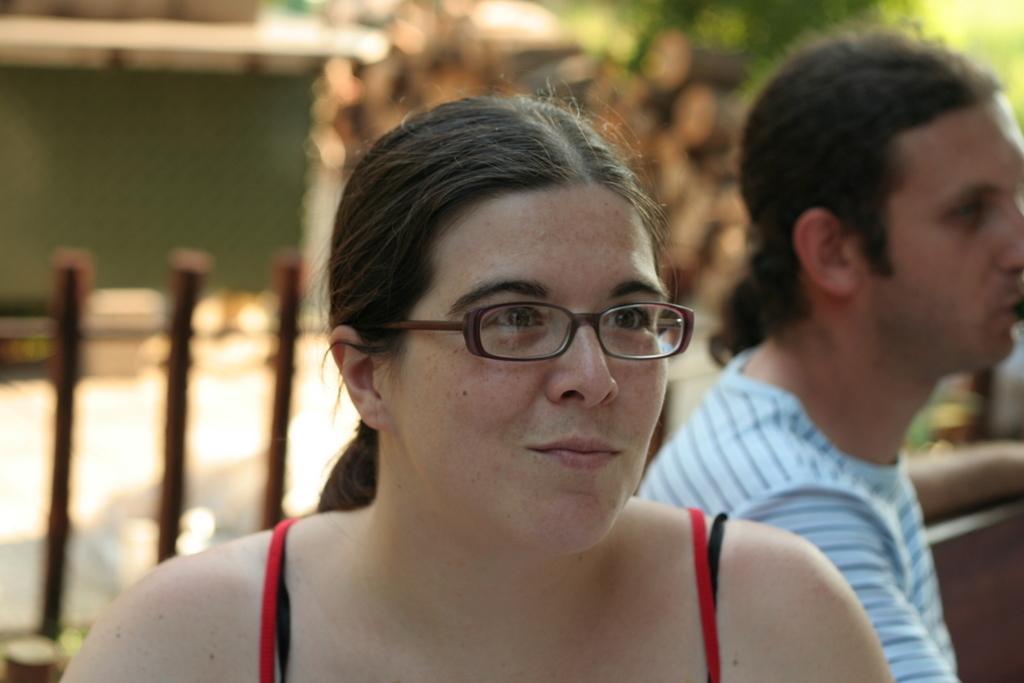How would you summarize this image in a sentence or two? In this picture, I can see two people behind this people few trees and a shop and also i can see a road after that i can see a chair. 